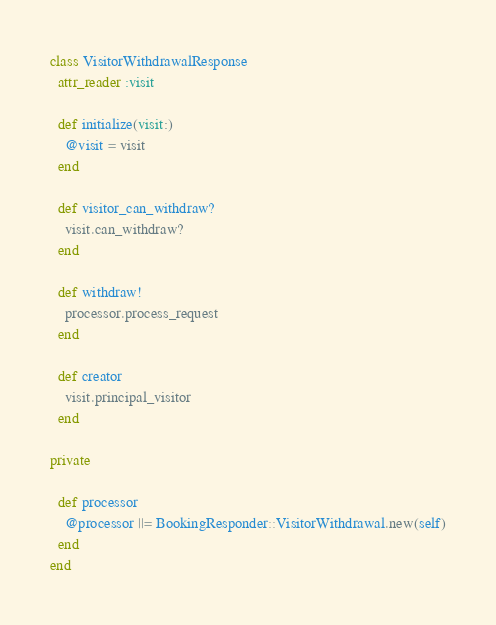<code> <loc_0><loc_0><loc_500><loc_500><_Ruby_>class VisitorWithdrawalResponse
  attr_reader :visit

  def initialize(visit:)
    @visit = visit
  end

  def visitor_can_withdraw?
    visit.can_withdraw?
  end

  def withdraw!
    processor.process_request
  end

  def creator
    visit.principal_visitor
  end

private

  def processor
    @processor ||= BookingResponder::VisitorWithdrawal.new(self)
  end
end
</code> 